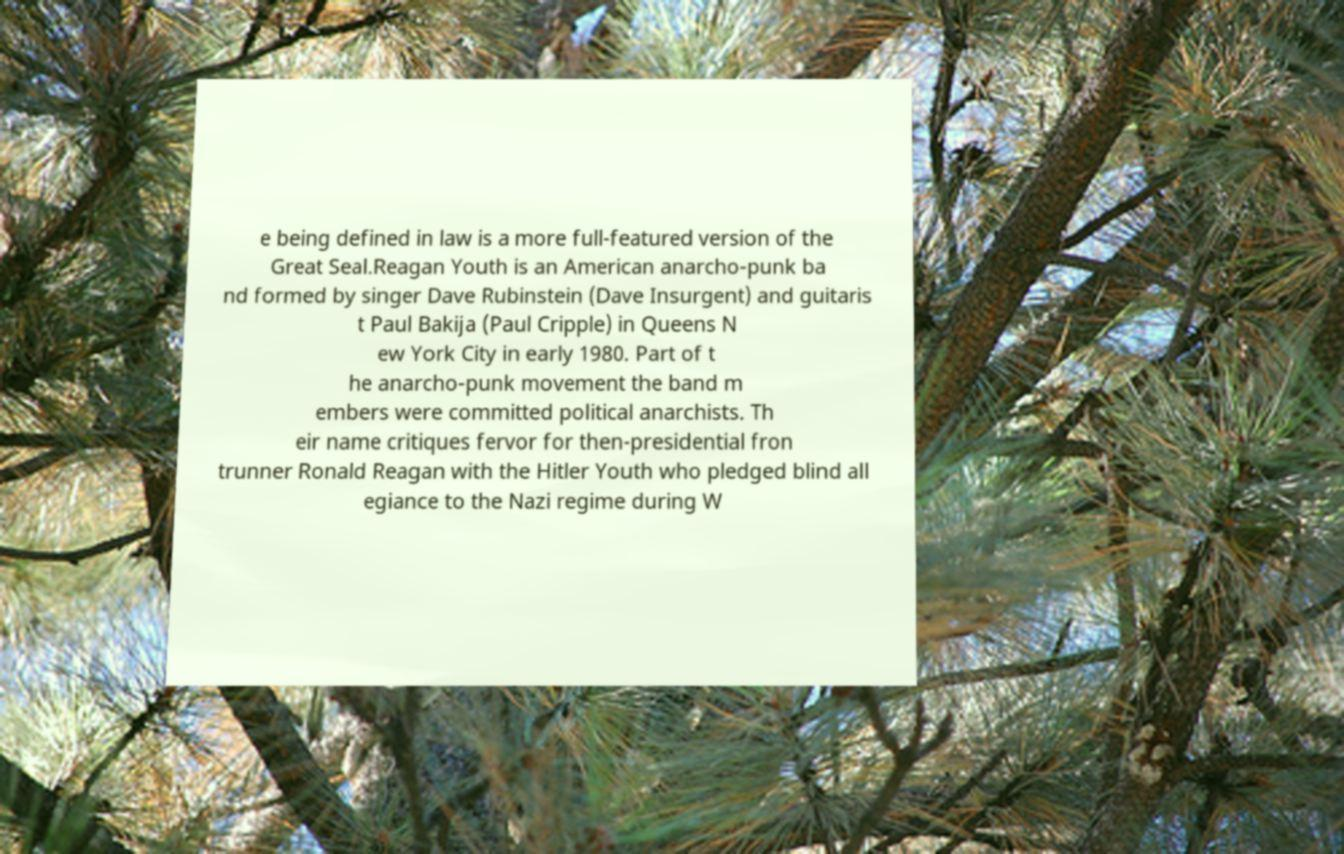Please read and relay the text visible in this image. What does it say? e being defined in law is a more full-featured version of the Great Seal.Reagan Youth is an American anarcho-punk ba nd formed by singer Dave Rubinstein (Dave Insurgent) and guitaris t Paul Bakija (Paul Cripple) in Queens N ew York City in early 1980. Part of t he anarcho-punk movement the band m embers were committed political anarchists. Th eir name critiques fervor for then-presidential fron trunner Ronald Reagan with the Hitler Youth who pledged blind all egiance to the Nazi regime during W 